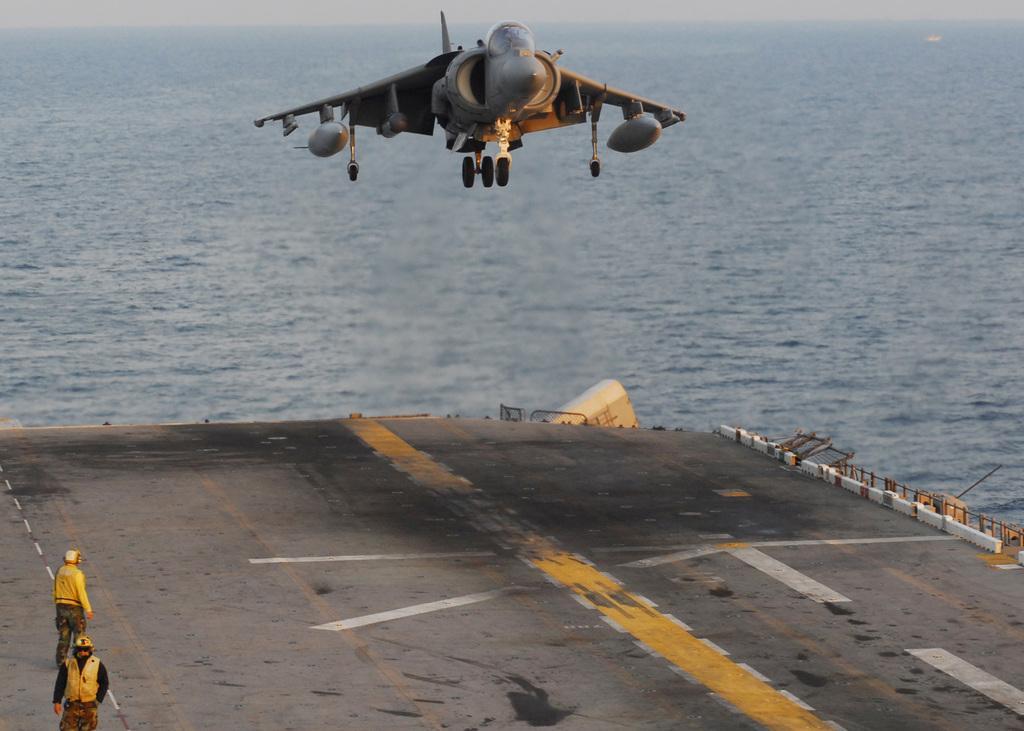Could you give a brief overview of what you see in this image? In this image I can see the runway, two persons wearing yellow colored jackets are standing on the runway and an aircraft which is grey and black in color is flying in the air. In the background I can see the water and the sky. 